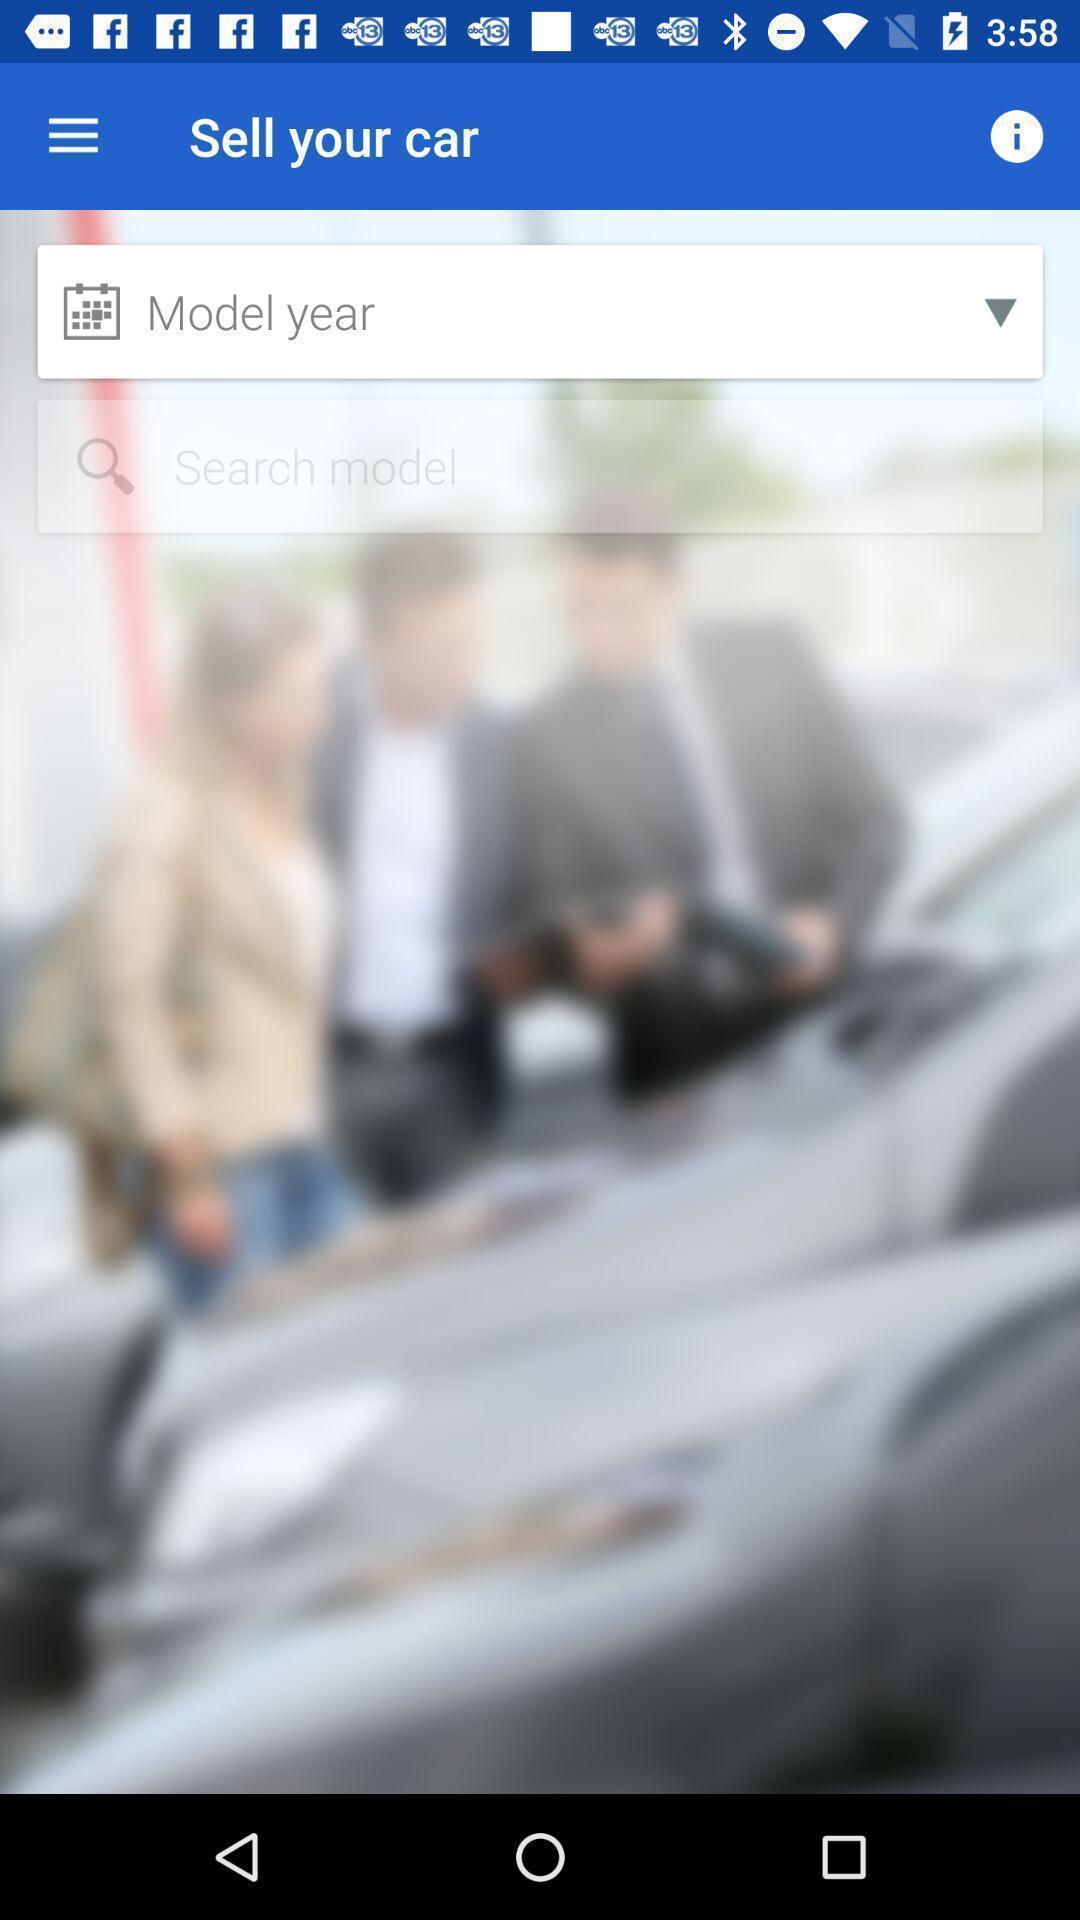What details can you identify in this image? Search bar to search the model of a car. 